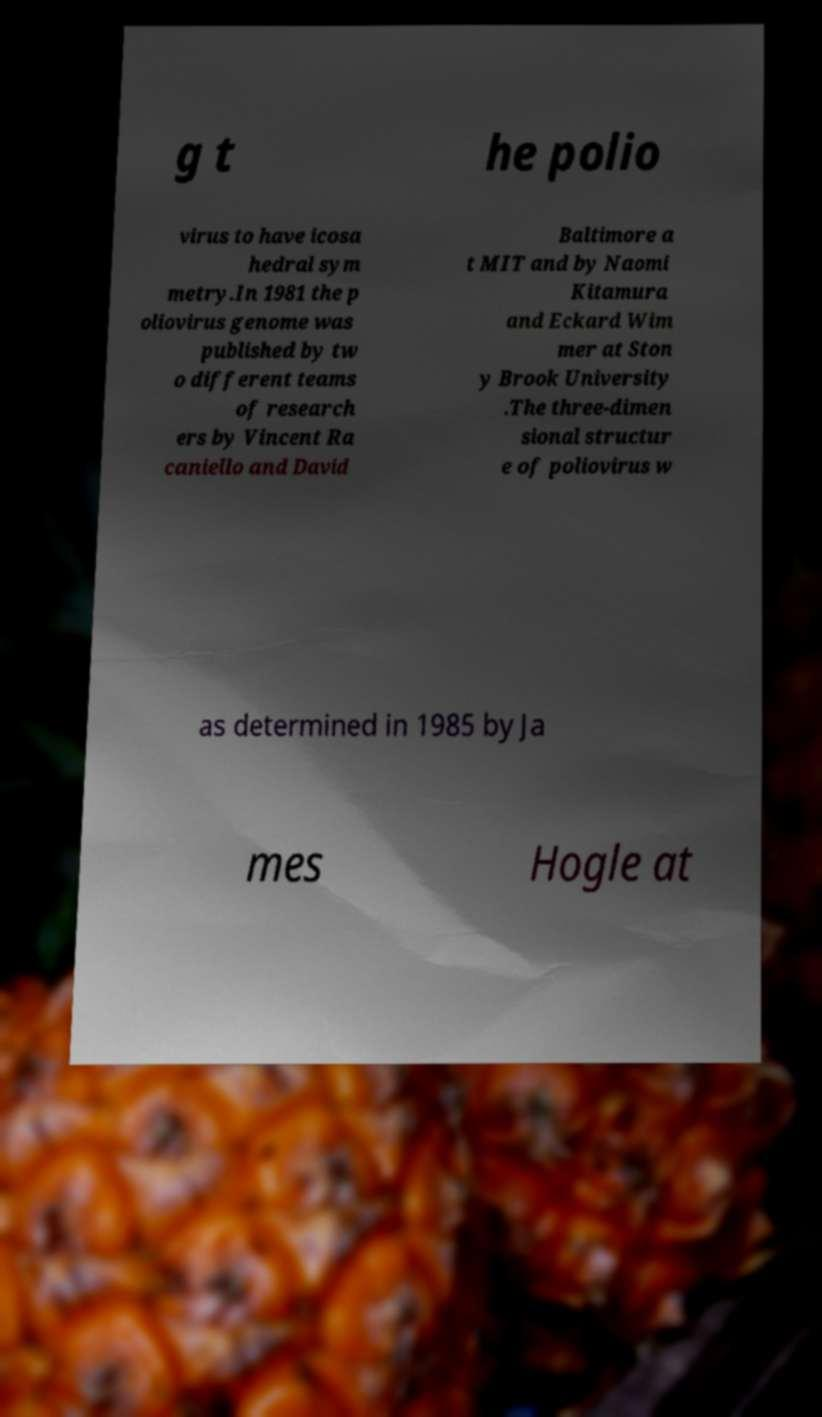Can you accurately transcribe the text from the provided image for me? g t he polio virus to have icosa hedral sym metry.In 1981 the p oliovirus genome was published by tw o different teams of research ers by Vincent Ra caniello and David Baltimore a t MIT and by Naomi Kitamura and Eckard Wim mer at Ston y Brook University .The three-dimen sional structur e of poliovirus w as determined in 1985 by Ja mes Hogle at 